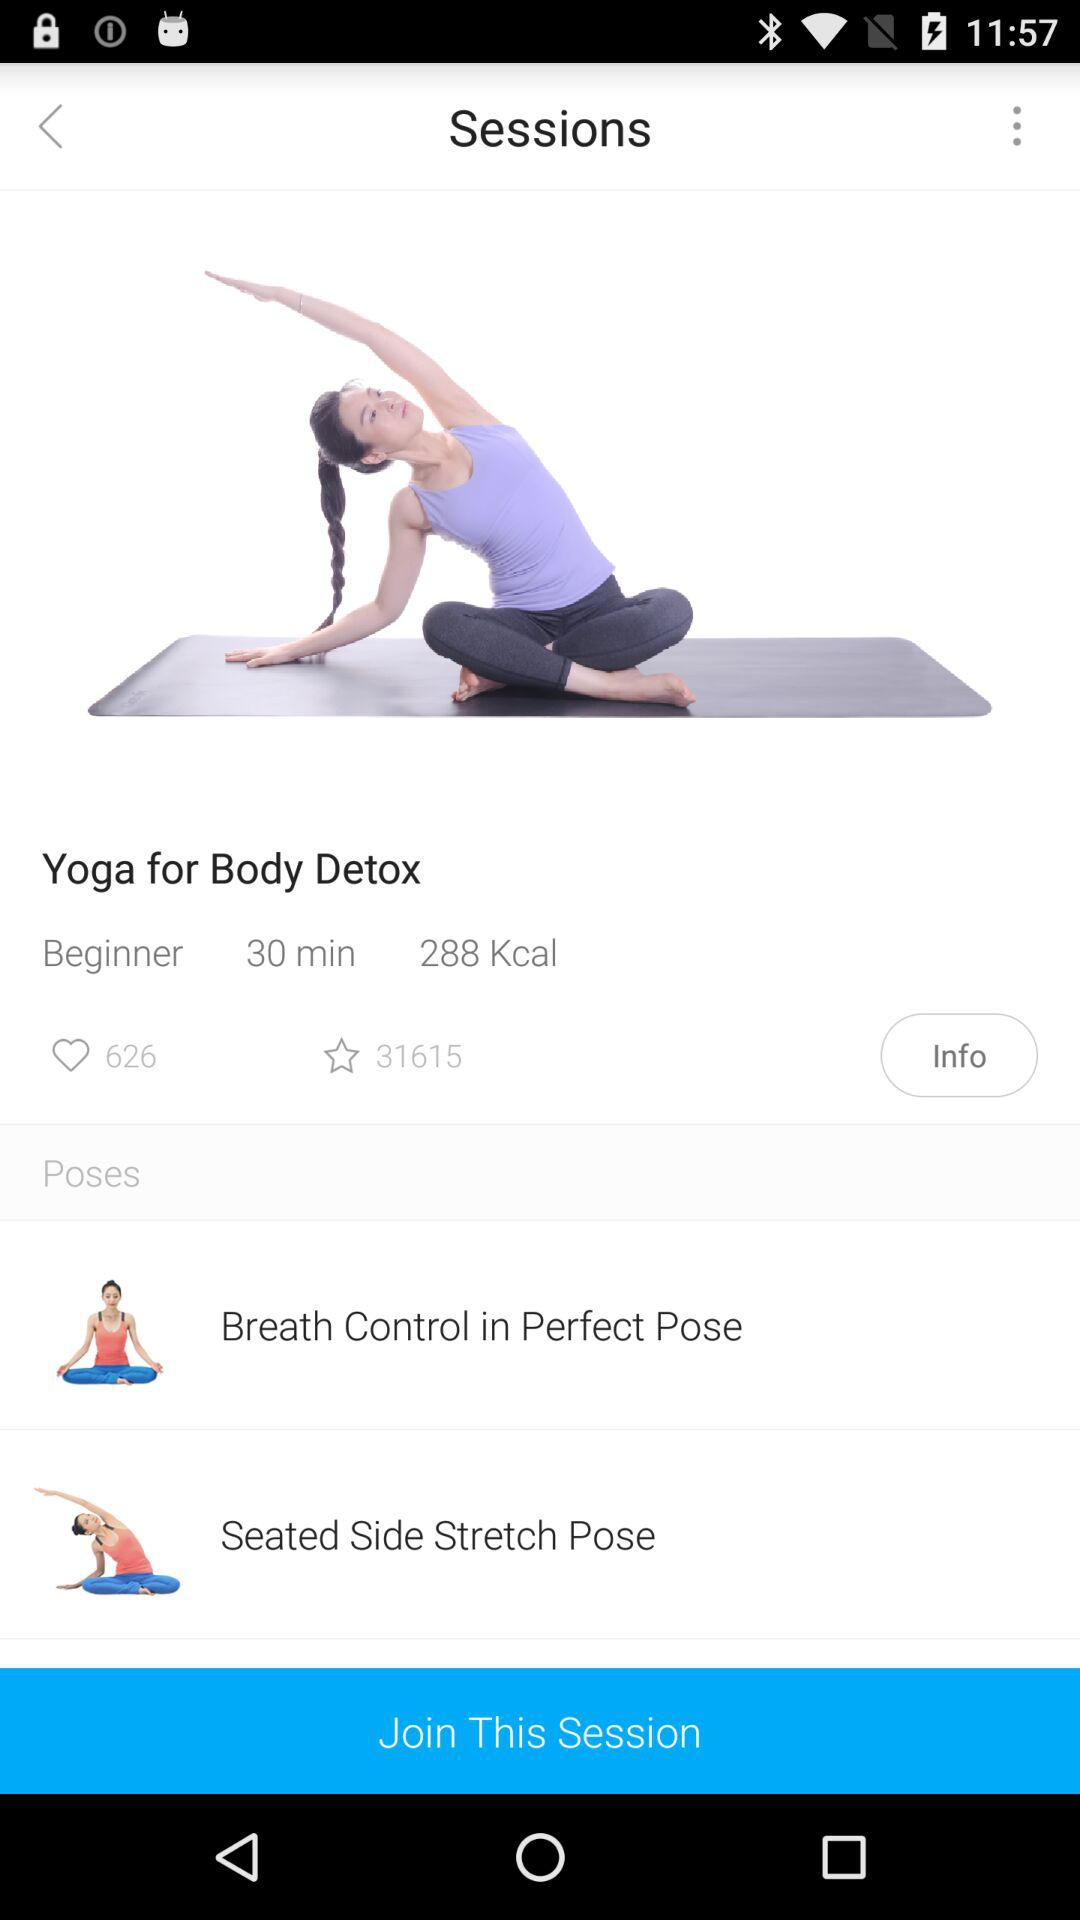How many poses are included in this session?
Answer the question using a single word or phrase. 2 